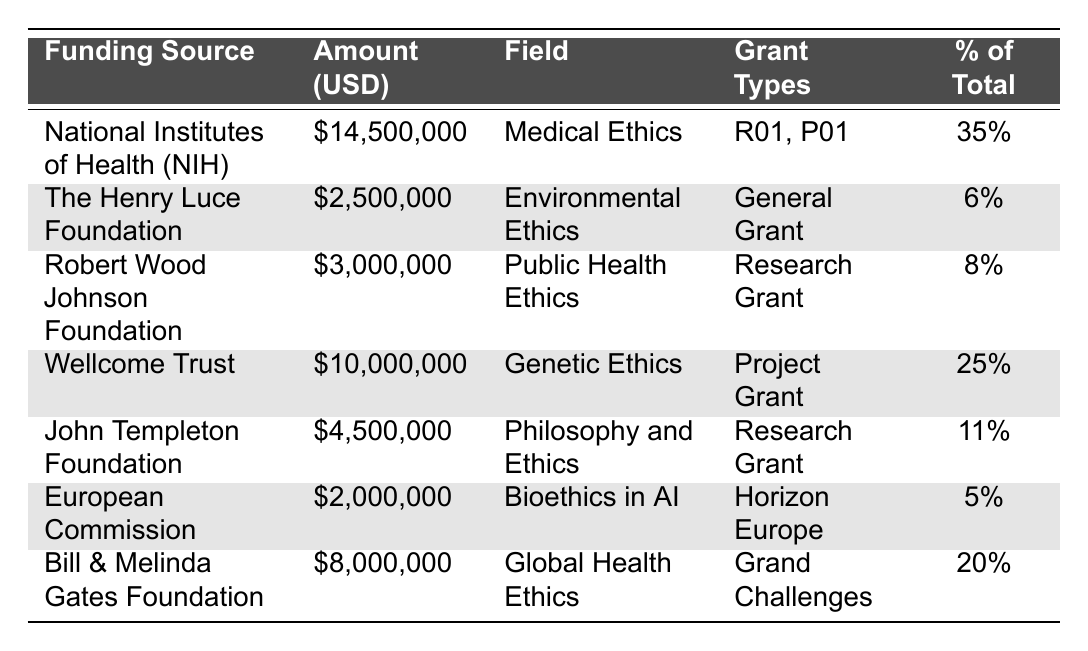What is the total funding amount from the National Institutes of Health (NIH)? The NIH funding amount listed in the table is $14,500,000.
Answer: $14,500,000 Which funding source accounts for the highest percentage of total funding? The NIH accounts for 35% of the total funding, which is the highest percentage among all sources.
Answer: National Institutes of Health (NIH) What is the combined funding amount from the Bill & Melinda Gates Foundation and Wellcome Trust? The combined funding amount is calculated as $8,000,000 (Gates) + $10,000,000 (Wellcome) = $18,000,000.
Answer: $18,000,000 Is the funding amount from the European Commission higher than that from the Robert Wood Johnson Foundation? The European Commission's funding amount is $2,000,000, while the Robert Wood Johnson Foundation's amount is $3,000,000, so the statement is false.
Answer: No What is the average funding amount per funding source listed in the table? The total funding amount is $14,500,000 + $2,500,000 + $3,000,000 + $10,000,000 + $4,500,000 + $2,000,000 + $8,000,000 = $44,500,000. There are 7 sources, so the average is $44,500,000 / 7 ≈ $6,357,143.
Answer: $6,357,143 How much funding is allocated to fields focusing on ethics in health (Medical, Public Health, and Global Health)? The funding amounts for Medical Ethics ($14,500,000), Public Health Ethics ($3,000,000), and Global Health Ethics ($8,000,000) are summed: $14,500,000 + $3,000,000 + $8,000,000 = $25,500,000.
Answer: $25,500,000 Which field of ethics received the least funding? The least funding is received by the European Commission with $2,000,000 for Bioethics in AI, which is the smallest amount listed.
Answer: Bioethics in AI What percentage of the total funding is accounted for by the top three funding sources? The top three sources are NIH (35%), Wellcome Trust (25%), and Bill & Melinda Gates Foundation (20%). Summing these percentages gives 35% + 25% + 20% = 80%.
Answer: 80% Is the combined funding for philosophy and ethics greater or less than that for Environmental Ethics? The combined funding for Philosophy and Ethics (John Templeton Foundation: $4,500,000) is greater than for Environmental Ethics (Henry Luce Foundation: $2,500,000); therefore, the statement is true.
Answer: Yes What is the difference in funding between the Wellcome Trust and the Robert Wood Johnson Foundation? The funding amounts are $10,000,000 (Wellcome) - $3,000,000 (Robert Wood Johnson) = $7,000,000 difference in funding.
Answer: $7,000,000 